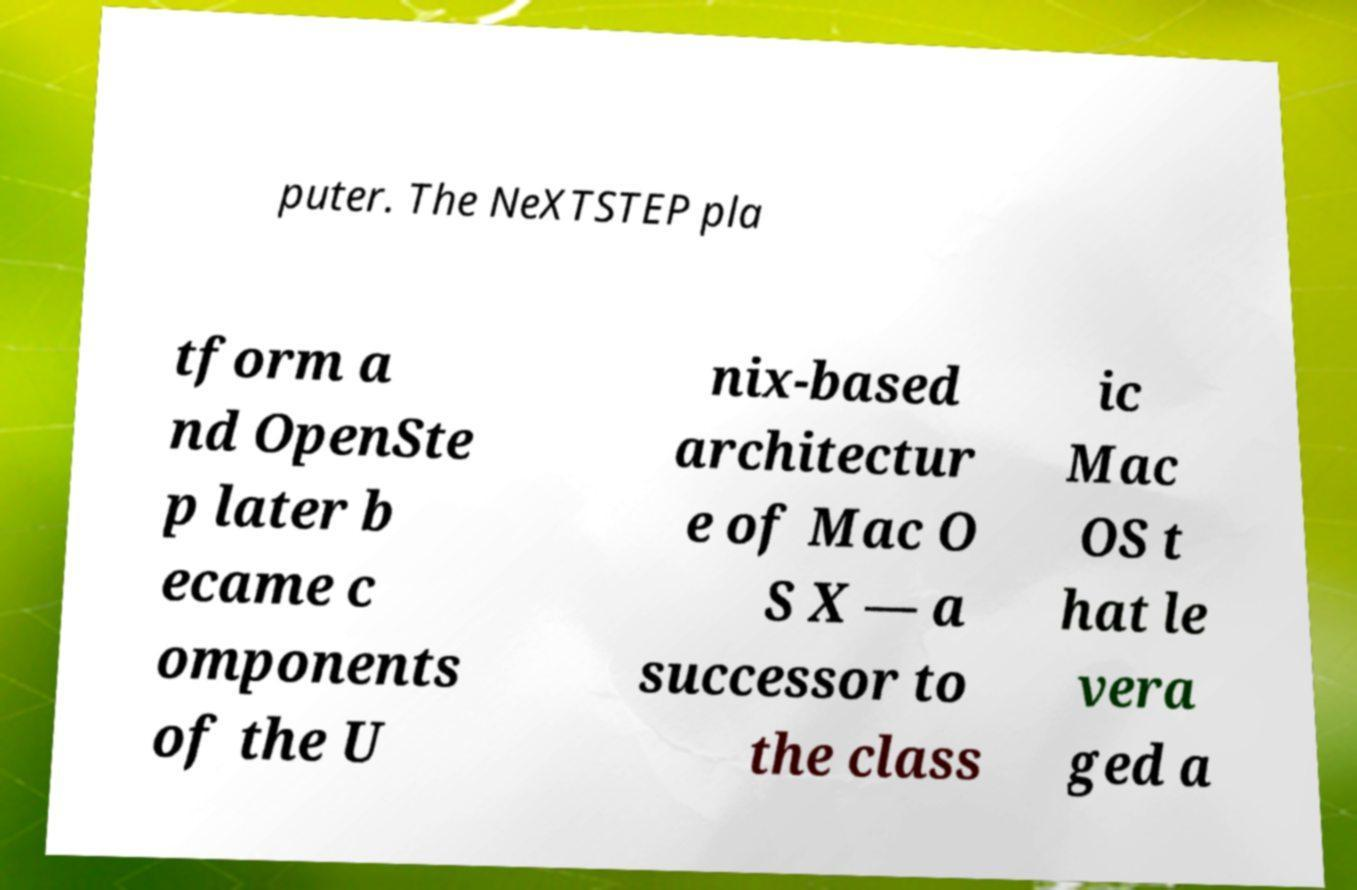Please read and relay the text visible in this image. What does it say? puter. The NeXTSTEP pla tform a nd OpenSte p later b ecame c omponents of the U nix-based architectur e of Mac O S X — a successor to the class ic Mac OS t hat le vera ged a 